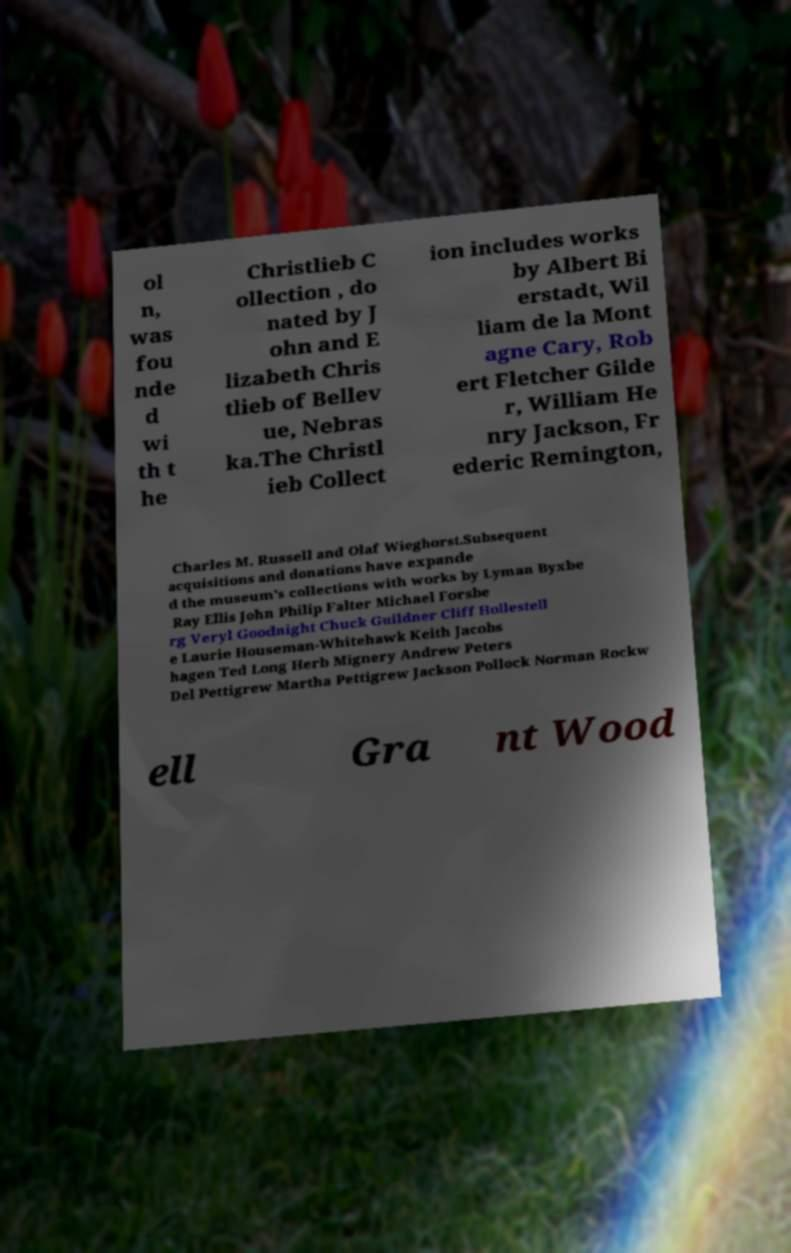Please identify and transcribe the text found in this image. ol n, was fou nde d wi th t he Christlieb C ollection , do nated by J ohn and E lizabeth Chris tlieb of Bellev ue, Nebras ka.The Christl ieb Collect ion includes works by Albert Bi erstadt, Wil liam de la Mont agne Cary, Rob ert Fletcher Gilde r, William He nry Jackson, Fr ederic Remington, Charles M. Russell and Olaf Wieghorst.Subsequent acquisitions and donations have expande d the museum's collections with works by Lyman Byxbe Ray Ellis John Philip Falter Michael Forsbe rg Veryl Goodnight Chuck Guildner Cliff Hollestell e Laurie Houseman-Whitehawk Keith Jacobs hagen Ted Long Herb Mignery Andrew Peters Del Pettigrew Martha Pettigrew Jackson Pollock Norman Rockw ell Gra nt Wood 